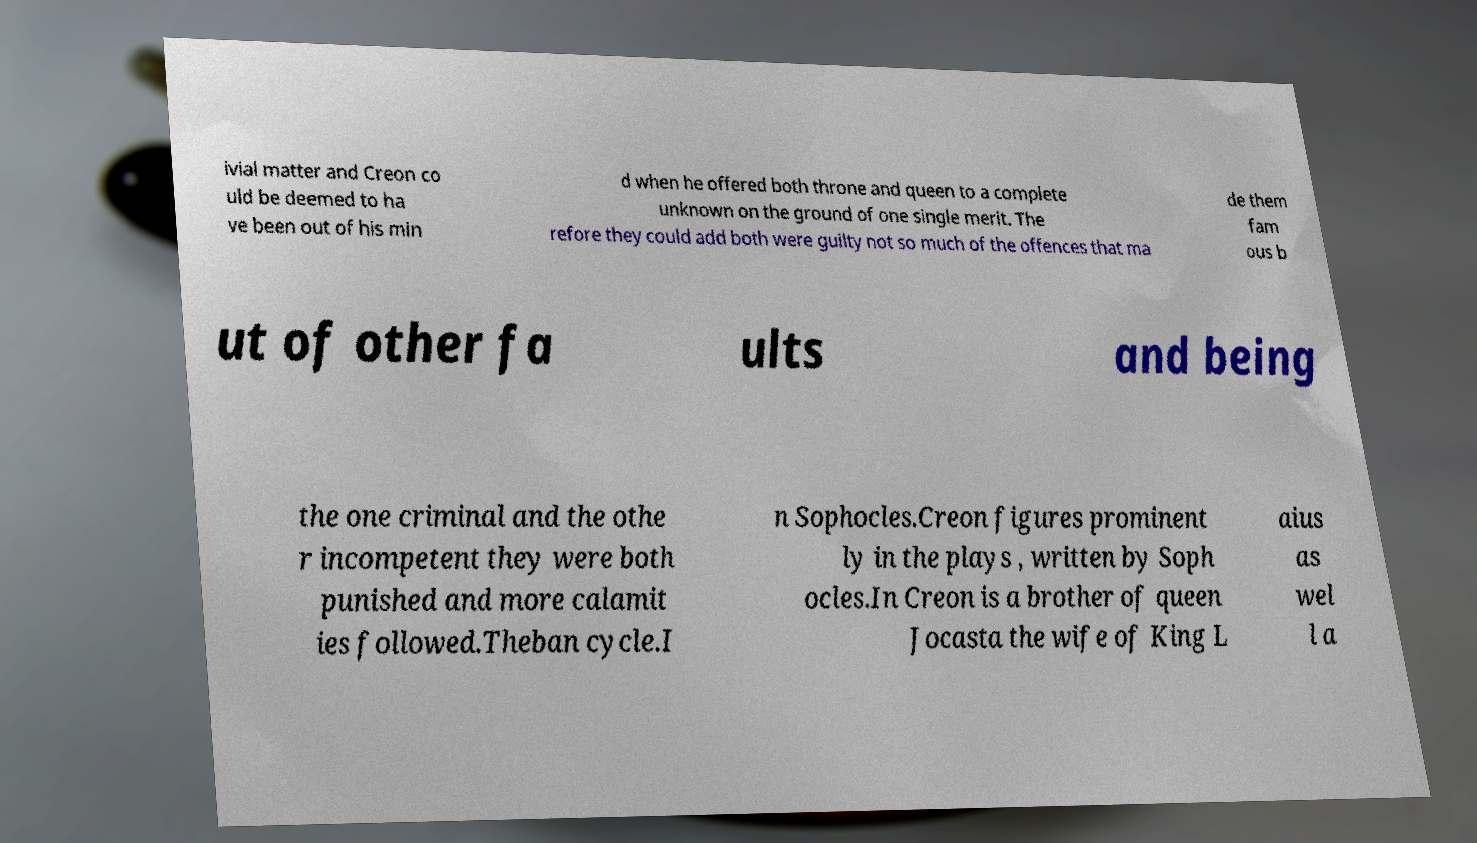Please read and relay the text visible in this image. What does it say? ivial matter and Creon co uld be deemed to ha ve been out of his min d when he offered both throne and queen to a complete unknown on the ground of one single merit. The refore they could add both were guilty not so much of the offences that ma de them fam ous b ut of other fa ults and being the one criminal and the othe r incompetent they were both punished and more calamit ies followed.Theban cycle.I n Sophocles.Creon figures prominent ly in the plays , written by Soph ocles.In Creon is a brother of queen Jocasta the wife of King L aius as wel l a 